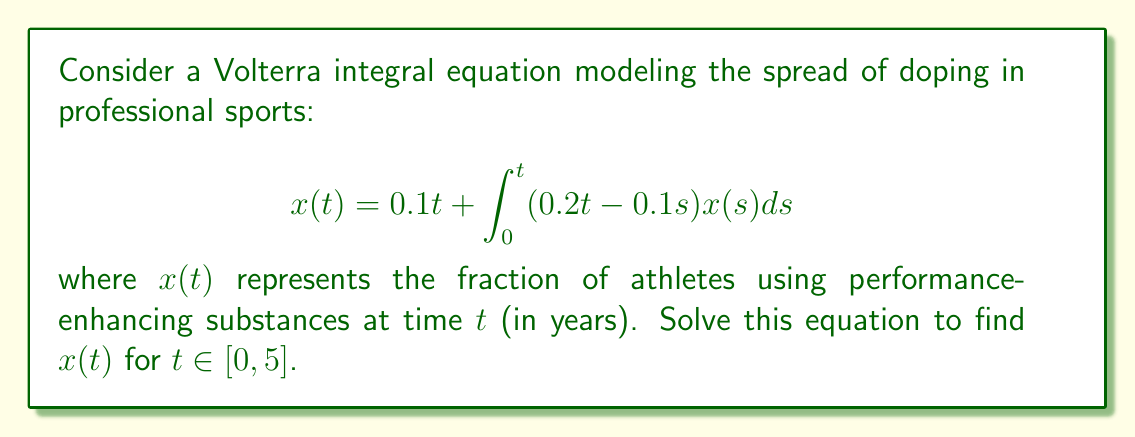Help me with this question. To solve this Volterra integral equation, we'll use the method of successive approximations:

1) Start with the initial approximation $x_0(t) = 0.1t$.

2) Substitute this into the right-hand side of the equation to get $x_1(t)$:

   $$x_1(t) = 0.1t + \int_0^t (0.2t - 0.1s)(0.1s)ds$$

3) Evaluate the integral:
   
   $$x_1(t) = 0.1t + 0.02t\int_0^t sds - 0.01\int_0^t s^2ds$$
   $$x_1(t) = 0.1t + 0.02t(\frac{t^2}{2}) - 0.01(\frac{t^3}{3})$$
   $$x_1(t) = 0.1t + 0.01t^3 - \frac{0.01t^3}{3} = 0.1t + \frac{0.02t^3}{3}$$

4) Repeat the process with $x_1(t)$:

   $$x_2(t) = 0.1t + \int_0^t (0.2t - 0.1s)(0.1s + \frac{0.02s^3}{3})ds$$

5) After evaluating this integral and simplifying, we get:

   $$x_2(t) = 0.1t + \frac{0.02t^3}{3} + \frac{0.002t^5}{15}$$

6) Continuing this process, we can see the pattern forming:

   $$x(t) = 0.1t + \frac{0.02t^3}{3} + \frac{0.002t^5}{15} + \frac{0.0002t^7}{105} + ...$$

7) This series can be expressed in closed form as:

   $$x(t) = \frac{\sinh(\sqrt{0.2}t)}{\sqrt{5}}$$

This solution is valid for $t \in [0, 5]$ as requested in the problem.
Answer: $x(t) = \frac{\sinh(\sqrt{0.2}t)}{\sqrt{5}}$ 